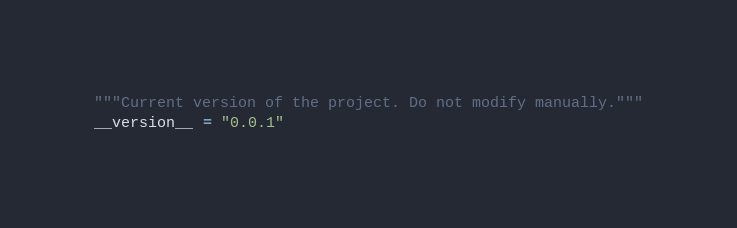<code> <loc_0><loc_0><loc_500><loc_500><_Python_>"""Current version of the project. Do not modify manually."""
__version__ = "0.0.1"
</code> 